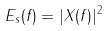Convert formula to latex. <formula><loc_0><loc_0><loc_500><loc_500>E _ { s } ( f ) = | X ( f ) | ^ { 2 }</formula> 